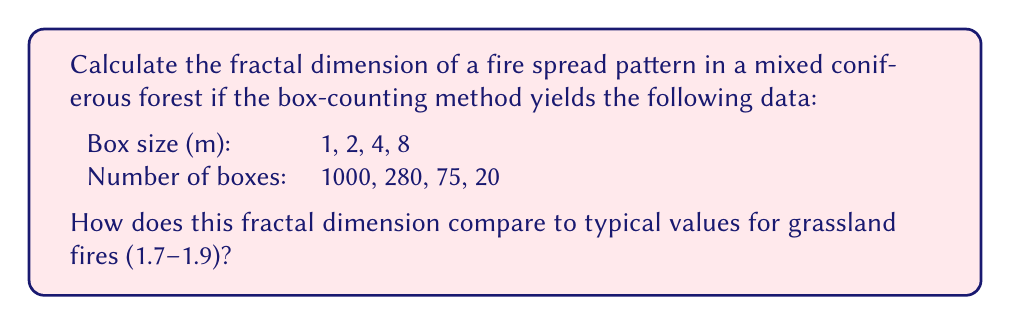Show me your answer to this math problem. To calculate the fractal dimension using the box-counting method, we follow these steps:

1) The fractal dimension $D$ is given by the slope of the log-log plot of box count vs. box size.

2) We use the formula:
   $$D = -\lim_{\epsilon \to 0} \frac{\log N(\epsilon)}{\log \epsilon}$$
   where $N(\epsilon)$ is the number of boxes of size $\epsilon$ needed to cover the pattern.

3) Let's create a table with $\log(\epsilon)$ and $\log(N(\epsilon))$:

   $\epsilon$ | $N(\epsilon)$ | $\log(\epsilon)$ | $\log(N(\epsilon))$
   1 | 1000 | 0 | 6.908
   2 | 280 | 0.693 | 5.635
   4 | 75 | 1.386 | 4.317
   8 | 20 | 2.079 | 2.996

4) We can find the slope using linear regression or by calculating:
   $$D \approx -\frac{\Delta \log N(\epsilon)}{\Delta \log \epsilon}$$

5) Using the first and last points:
   $$D \approx -\frac{2.996 - 6.908}{2.079 - 0} \approx 1.88$$

6) This fractal dimension (1.88) falls within the typical range for grassland fires (1.7-1.9), suggesting that the fire spread pattern in this mixed coniferous forest exhibits similar complexity to grassland fires.

7) However, it's on the higher end of the range, indicating a slightly more complex spread pattern than average grassland fires. This could be due to the varied structure and fuel distribution in a mixed coniferous forest compared to more uniform grasslands.
Answer: $D \approx 1.88$, within typical grassland fire range but higher complexity. 